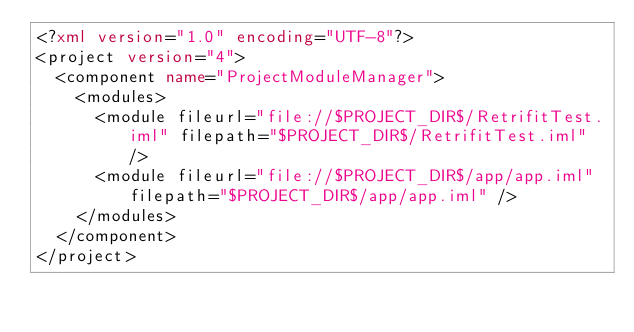Convert code to text. <code><loc_0><loc_0><loc_500><loc_500><_XML_><?xml version="1.0" encoding="UTF-8"?>
<project version="4">
  <component name="ProjectModuleManager">
    <modules>
      <module fileurl="file://$PROJECT_DIR$/RetrifitTest.iml" filepath="$PROJECT_DIR$/RetrifitTest.iml" />
      <module fileurl="file://$PROJECT_DIR$/app/app.iml" filepath="$PROJECT_DIR$/app/app.iml" />
    </modules>
  </component>
</project></code> 